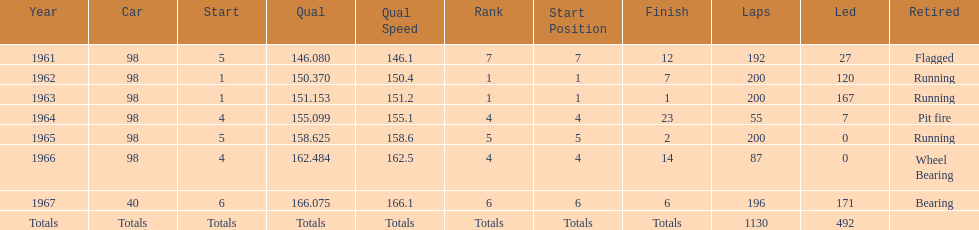In which years did he lead the race the least? 1965, 1966. 